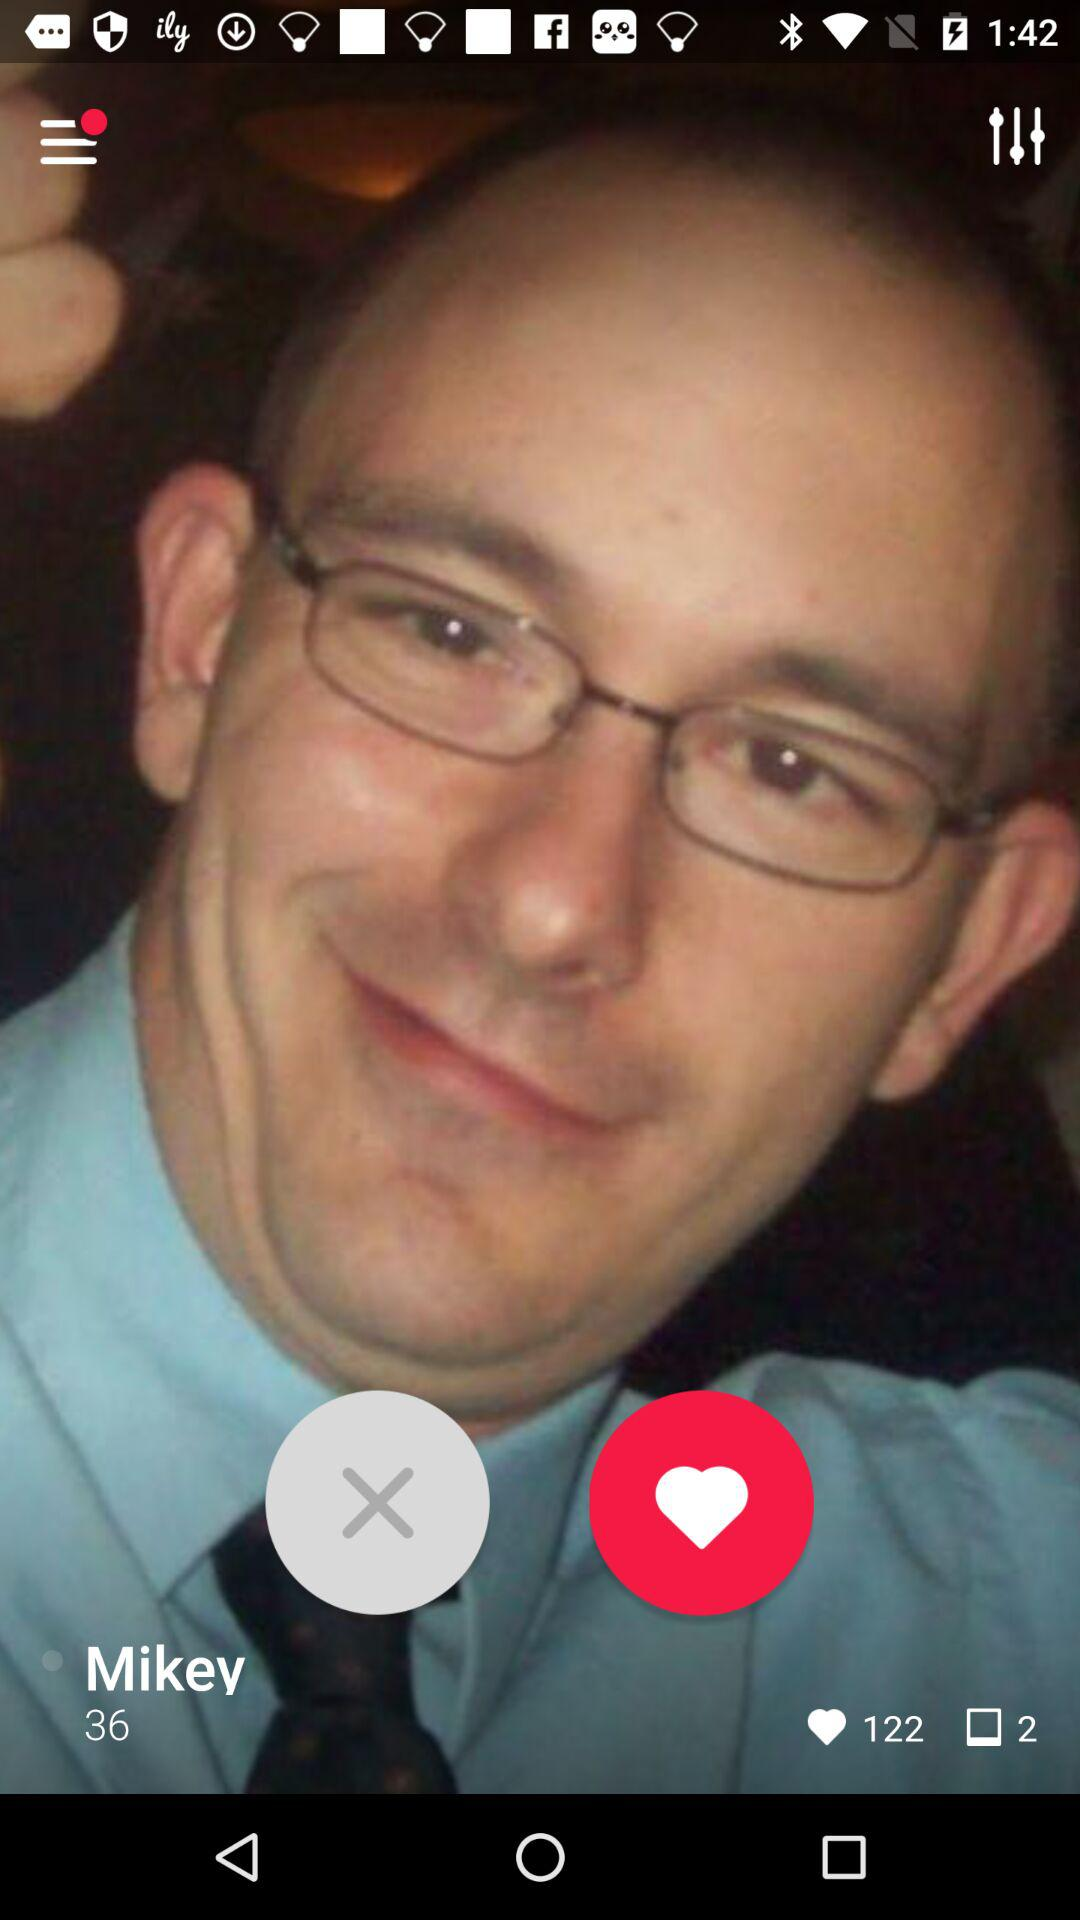What is the age of the person? The person is 36 years old. 